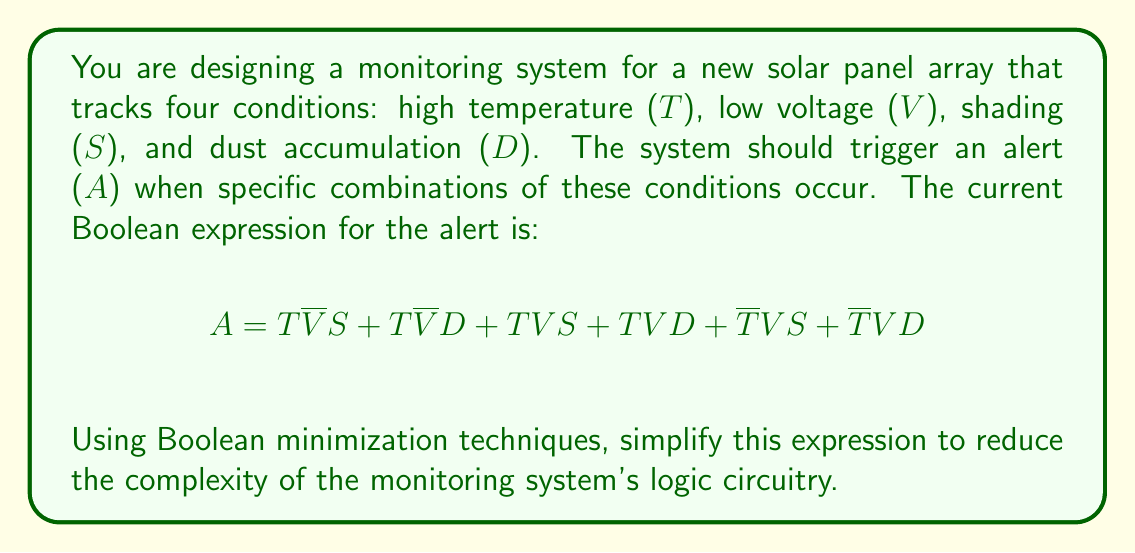What is the answer to this math problem? Let's simplify this Boolean expression step by step using Boolean algebra laws and Karnaugh maps:

1. First, let's group the terms with T and $\overline{T}$:
   $$A = T(\overline{V}S + \overline{V}D + VS + VD) + \overline{T}(VS + VD)$$

2. Simplify the expression inside the first parentheses:
   $$T(\overline{V}S + \overline{V}D + VS + VD) = T(\overline{V}(S + D) + V(S + D))$$
   $$= T(S + D)(\overline{V} + V) = T(S + D)$$

3. The expression now becomes:
   $$A = T(S + D) + \overline{T}(VS + VD)$$

4. Factor out (S + D) from both terms:
   $$A = (S + D)(T + \overline{T}V)$$

5. Simplify $T + \overline{T}V$ using the absorption law:
   $$T + \overline{T}V = T + V$$

6. The final simplified expression is:
   $$A = (S + D)(T + V)$$

This simplified expression means that an alert should be triggered when either shading (S) or dust accumulation (D) occurs, AND either high temperature (T) or low voltage (V) is present.
Answer: $A = (S + D)(T + V)$ 